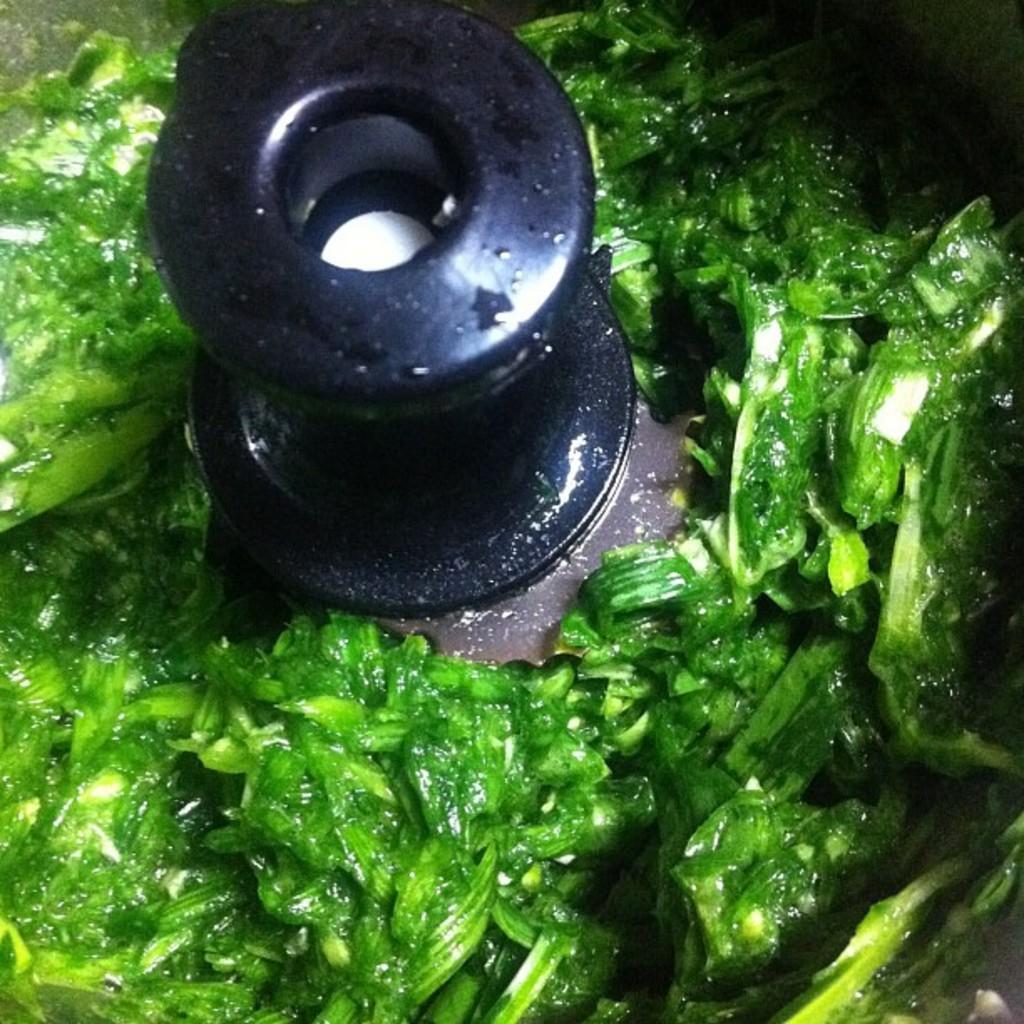Can you describe this image briefly? In this picture we can see green color food item, in a mixer or a grinder. 